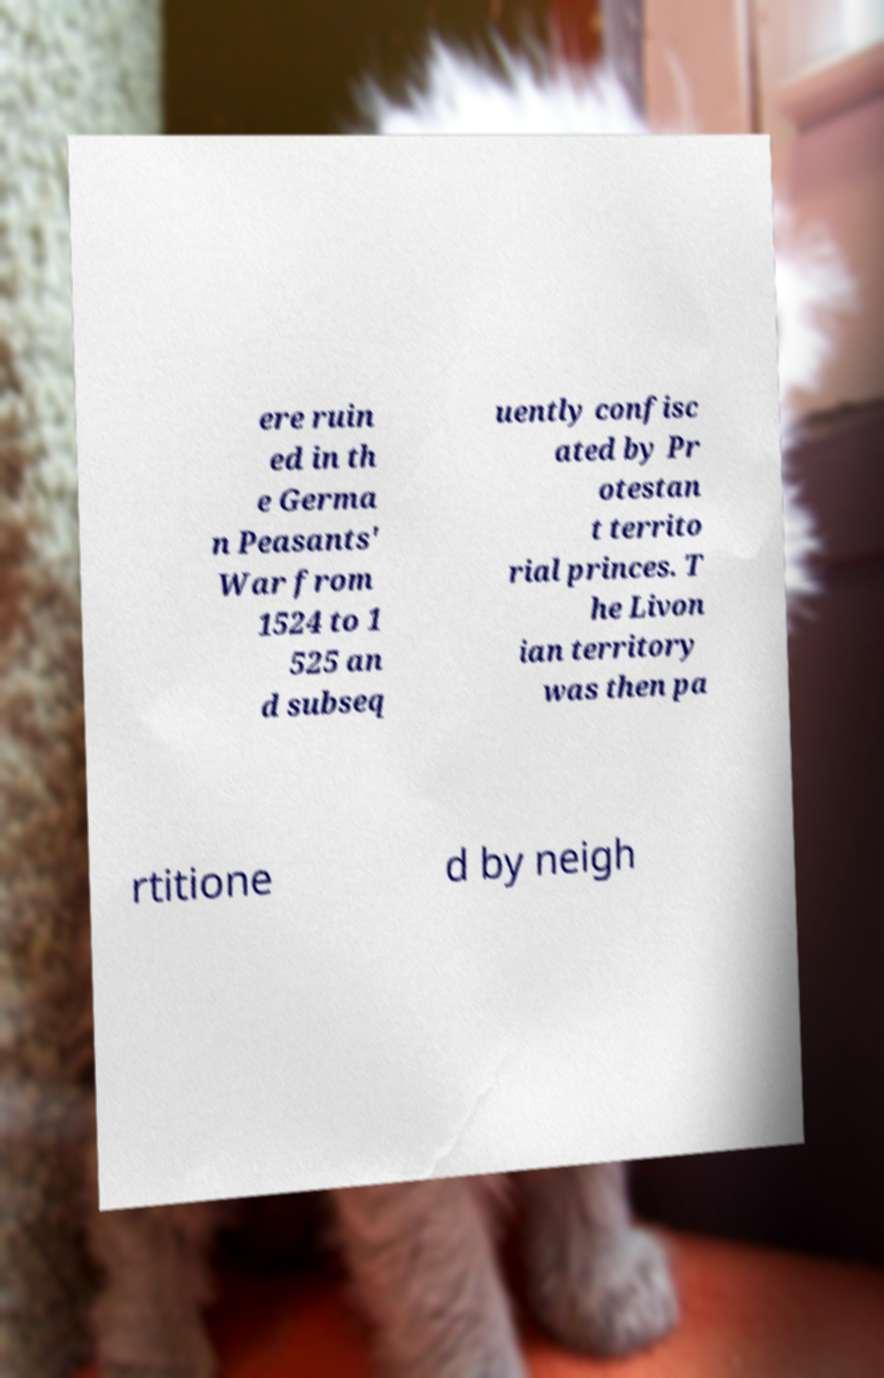Could you extract and type out the text from this image? ere ruin ed in th e Germa n Peasants' War from 1524 to 1 525 an d subseq uently confisc ated by Pr otestan t territo rial princes. T he Livon ian territory was then pa rtitione d by neigh 